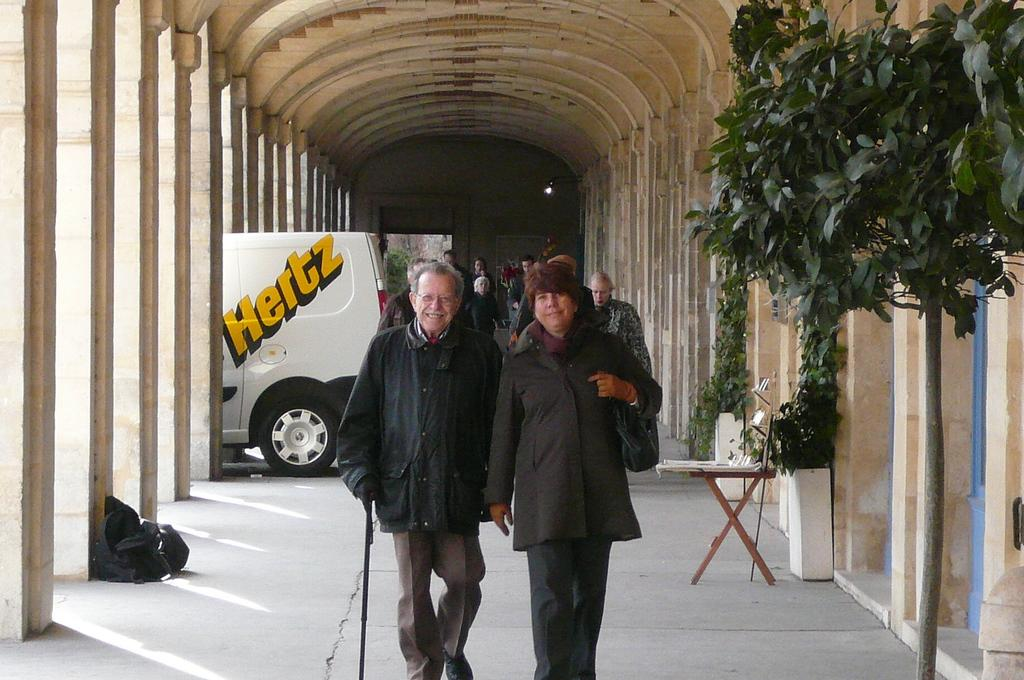What are the persons in the image doing? The persons in the image are on the floor. What can be seen in the background of the image? There are arches, a motor vehicle, a backpack, a side table, a plant, and creepers in the background of the image. Where is the mailbox located in the image? There is no mailbox present in the image. How low are the creepers in the image? The provided facts do not specify the height of the creepers, so it cannot be determined from the image. 